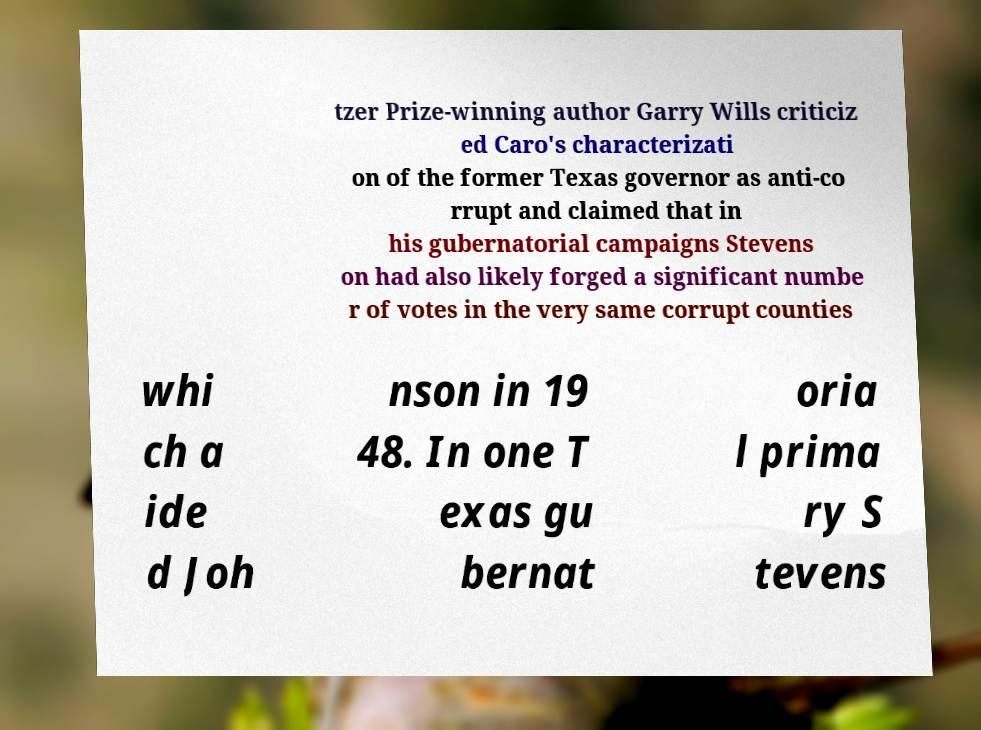I need the written content from this picture converted into text. Can you do that? tzer Prize-winning author Garry Wills criticiz ed Caro's characterizati on of the former Texas governor as anti-co rrupt and claimed that in his gubernatorial campaigns Stevens on had also likely forged a significant numbe r of votes in the very same corrupt counties whi ch a ide d Joh nson in 19 48. In one T exas gu bernat oria l prima ry S tevens 